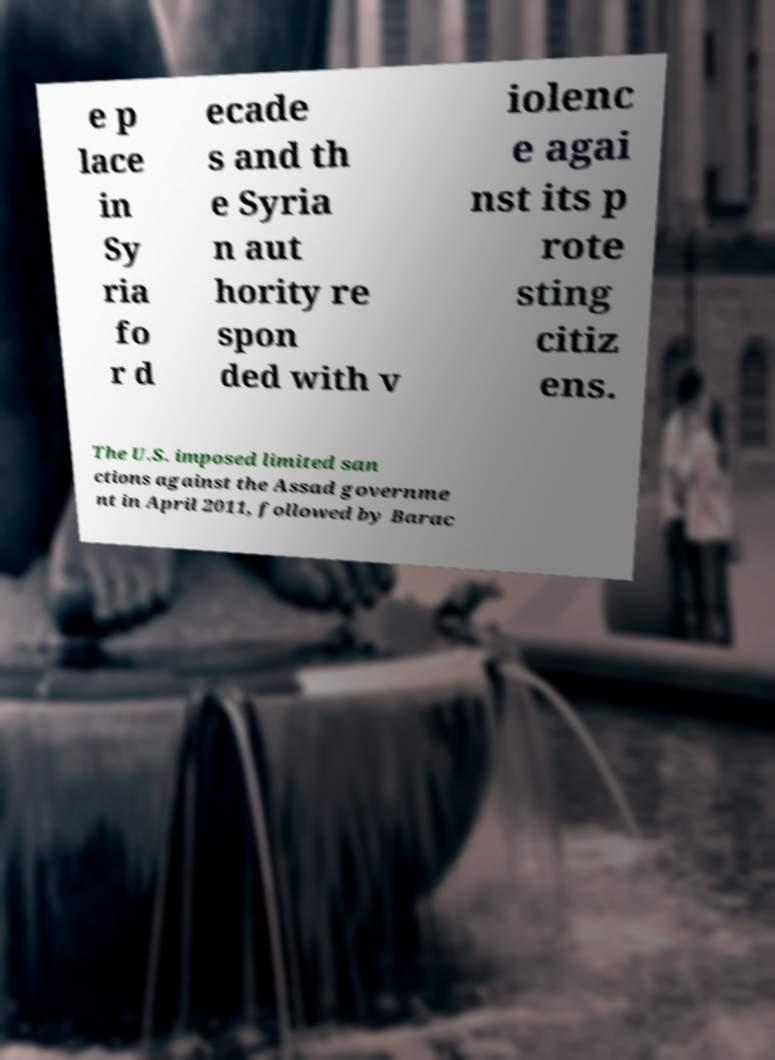Can you read and provide the text displayed in the image?This photo seems to have some interesting text. Can you extract and type it out for me? e p lace in Sy ria fo r d ecade s and th e Syria n aut hority re spon ded with v iolenc e agai nst its p rote sting citiz ens. The U.S. imposed limited san ctions against the Assad governme nt in April 2011, followed by Barac 